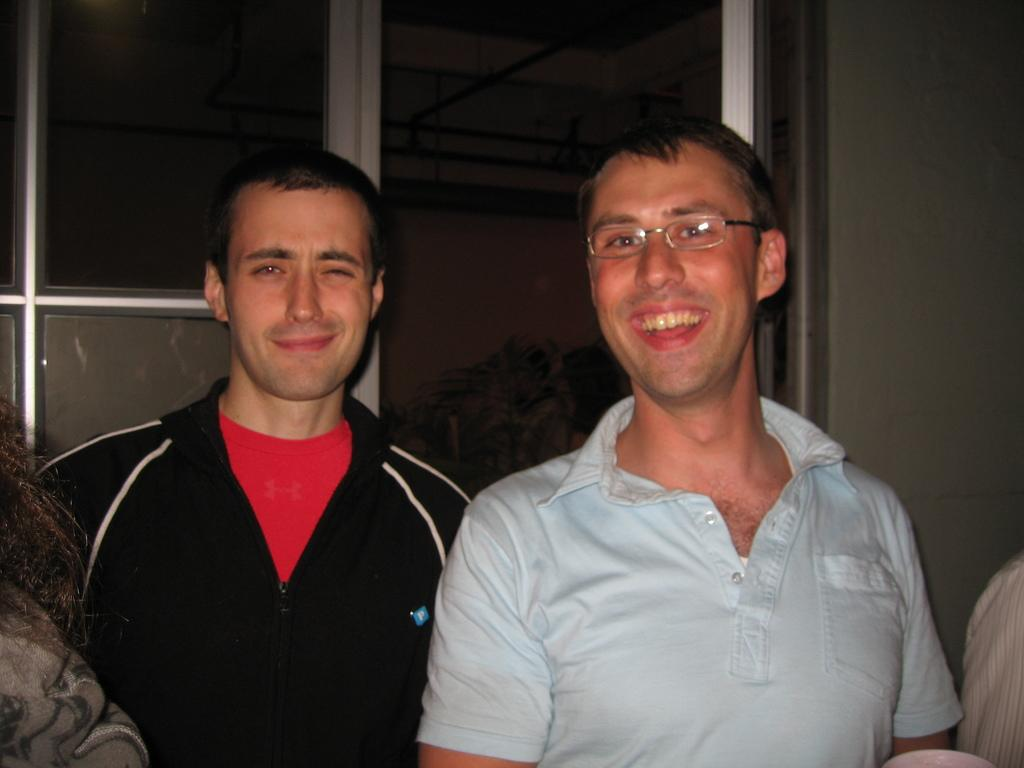How many people are in the image? There are people in the image, but the exact number is not specified. Can you describe any specific features of one of the people? One person is wearing spectacles. What can be seen in the background of the image? There are plants in the background of the image. What type of screw is being used to hold the theory together in the image? There is no mention of a theory or screw in the image, so this question cannot be answered. 